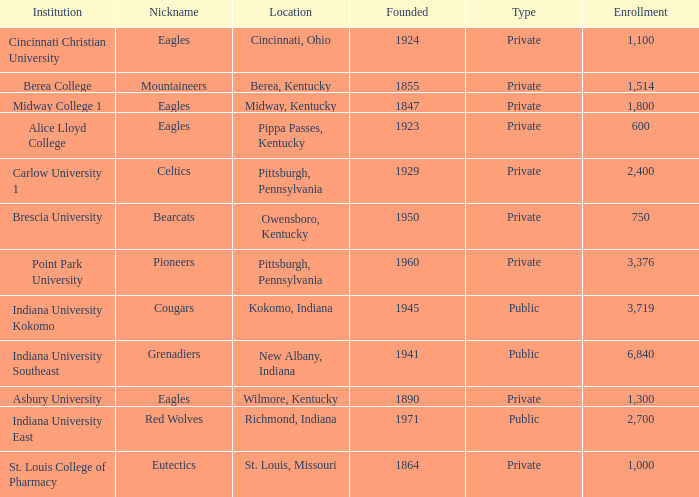Which of the private colleges is the oldest, and whose nickname is the Mountaineers? 1855.0. 